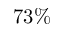<formula> <loc_0><loc_0><loc_500><loc_500>7 3 \%</formula> 